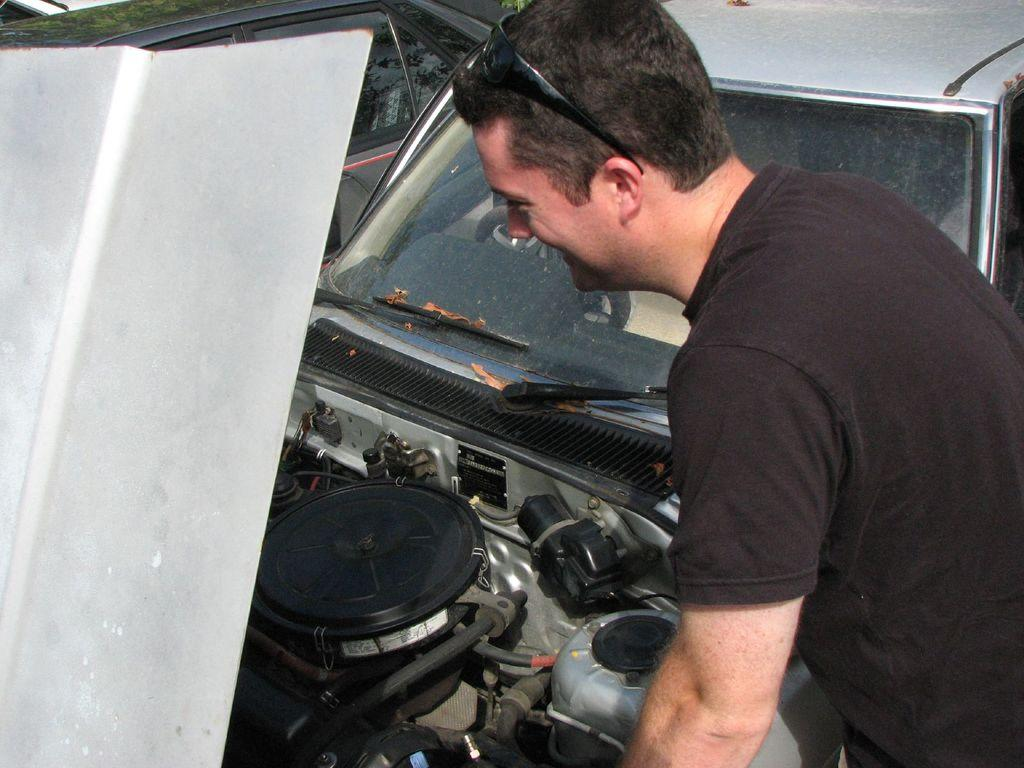Who is present in the image? There is a man in the image. Where is the man located in the image? The man is on the right side of the image. What is in front of the man in the image? There is a car in front of the man. Are there any other cars in the image? Yes, there is another car in the image. What type of pan is the man using to cook in the image? There is no pan or cooking activity present in the image. 